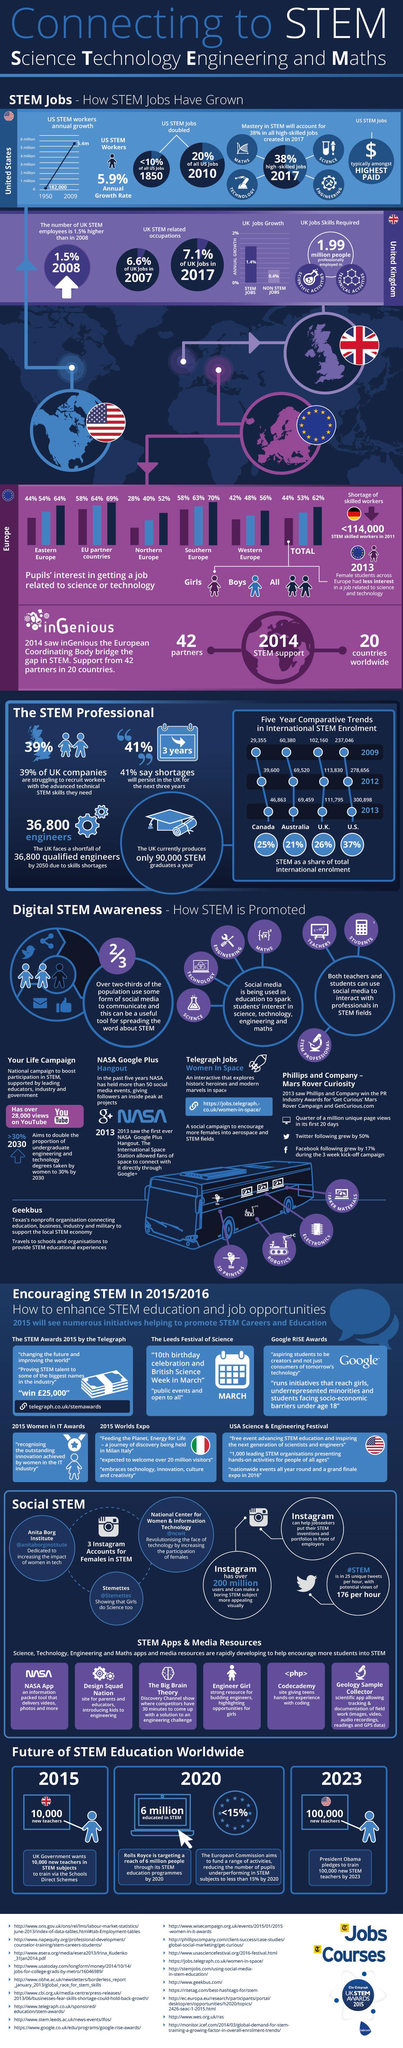Mention a couple of crucial points in this snapshot. In Western Europe, a significant majority of both girls and boys are successfully securing employment in fields related to science and technology, with 90% of them combined. The United States STEM jobs are the highest paid jobs in the country. According to recent data in the UK, the combined percentage of stem (science, technology, engineering, and math) and non-stem jobs is 1.8%. According to data from Eastern Europe, a significant majority of both girls and boys, approximately 98%, are successfully obtaining employment in fields related to science and technology. 